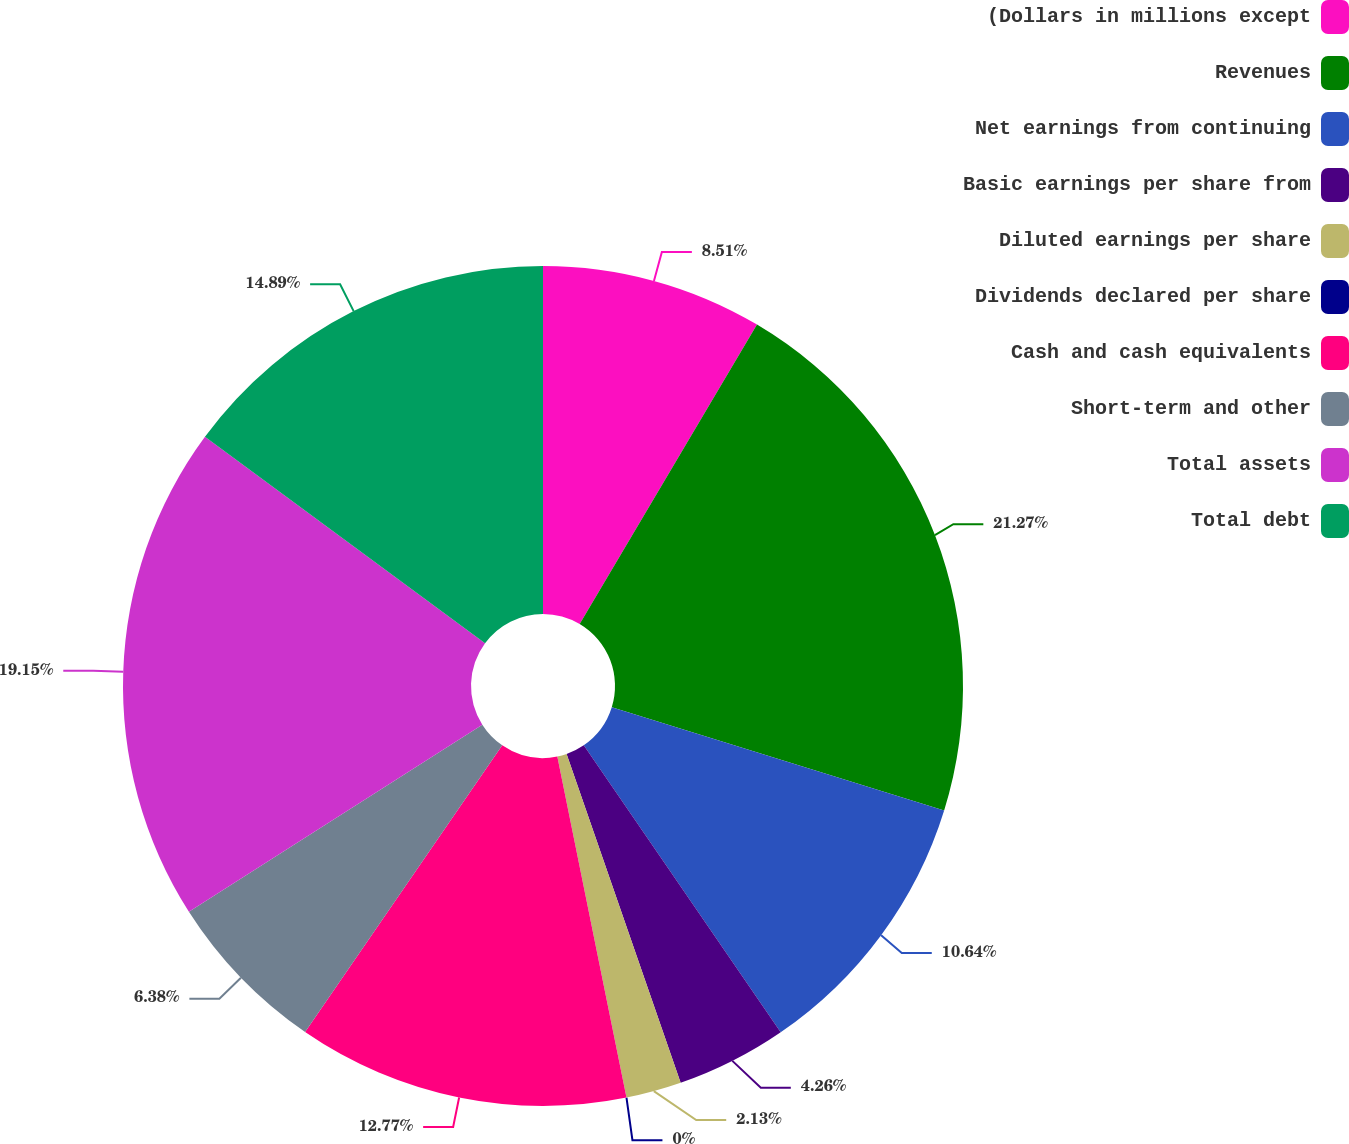Convert chart to OTSL. <chart><loc_0><loc_0><loc_500><loc_500><pie_chart><fcel>(Dollars in millions except<fcel>Revenues<fcel>Net earnings from continuing<fcel>Basic earnings per share from<fcel>Diluted earnings per share<fcel>Dividends declared per share<fcel>Cash and cash equivalents<fcel>Short-term and other<fcel>Total assets<fcel>Total debt<nl><fcel>8.51%<fcel>21.28%<fcel>10.64%<fcel>4.26%<fcel>2.13%<fcel>0.0%<fcel>12.77%<fcel>6.38%<fcel>19.15%<fcel>14.89%<nl></chart> 